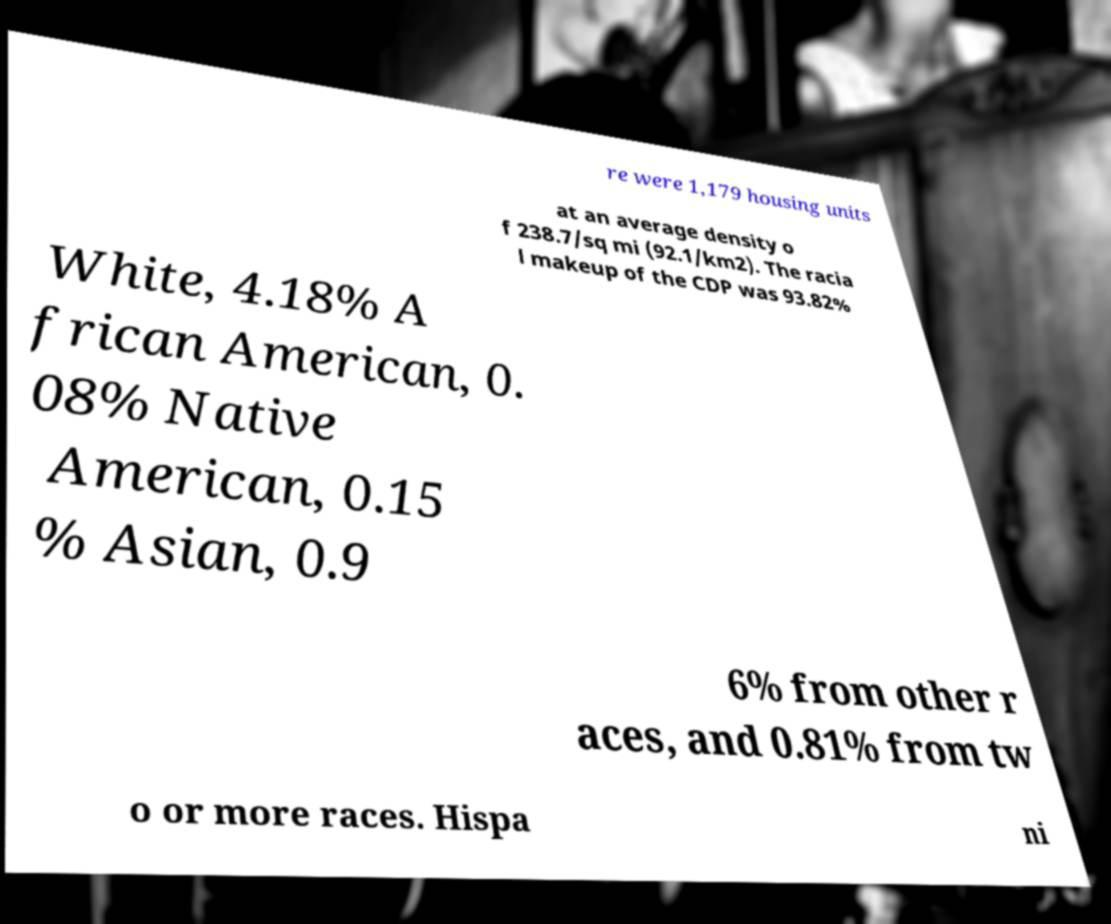Can you accurately transcribe the text from the provided image for me? re were 1,179 housing units at an average density o f 238.7/sq mi (92.1/km2). The racia l makeup of the CDP was 93.82% White, 4.18% A frican American, 0. 08% Native American, 0.15 % Asian, 0.9 6% from other r aces, and 0.81% from tw o or more races. Hispa ni 